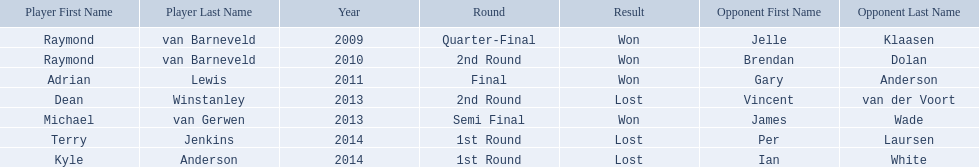Who are the players at the pdc world darts championship? Raymond van Barneveld, Raymond van Barneveld, Adrian Lewis, Dean Winstanley, Michael van Gerwen, Terry Jenkins, Kyle Anderson. When did kyle anderson lose? 2014. Which other players lost in 2014? Terry Jenkins. 